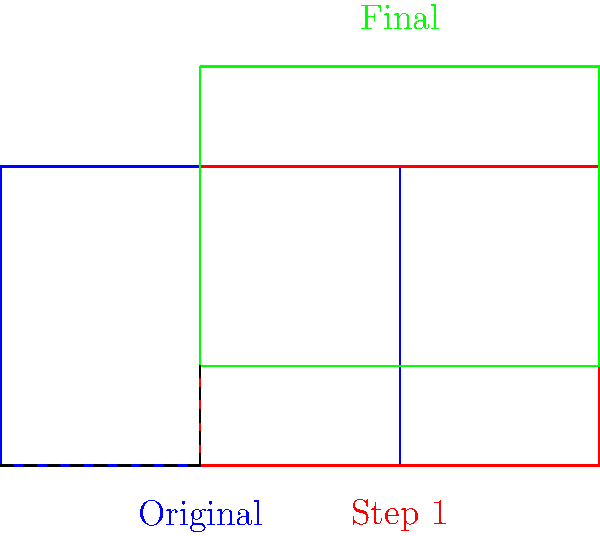For an international event, you need to redesign the seating chart. The original rectangular seating area (blue) undergoes two transformations: first, a translation of 2 units right (red), then a translation of 1 unit up (green). What single transformation could achieve the same result as these two consecutive translations? To solve this problem, we need to analyze the composite transformation:

1. First translation: $T_1(x,y) = (x+2, y)$
2. Second translation: $T_2(x,y) = (x, y+1)$

The composite transformation $T$ is:
$T(x,y) = T_2(T_1(x,y)) = T_2(x+2, y) = (x+2, y+1)$

This composite transformation can be expressed as a single translation:

$T(x,y) = (x+2, y+1) = (x,y) + (2,1)$

Therefore, the single transformation that achieves the same result is a translation by the vector $(2,1)$.

In the context of the seating chart, this means moving all seats 2 units to the right and 1 unit up simultaneously.
Answer: Translation by vector $(2,1)$ 